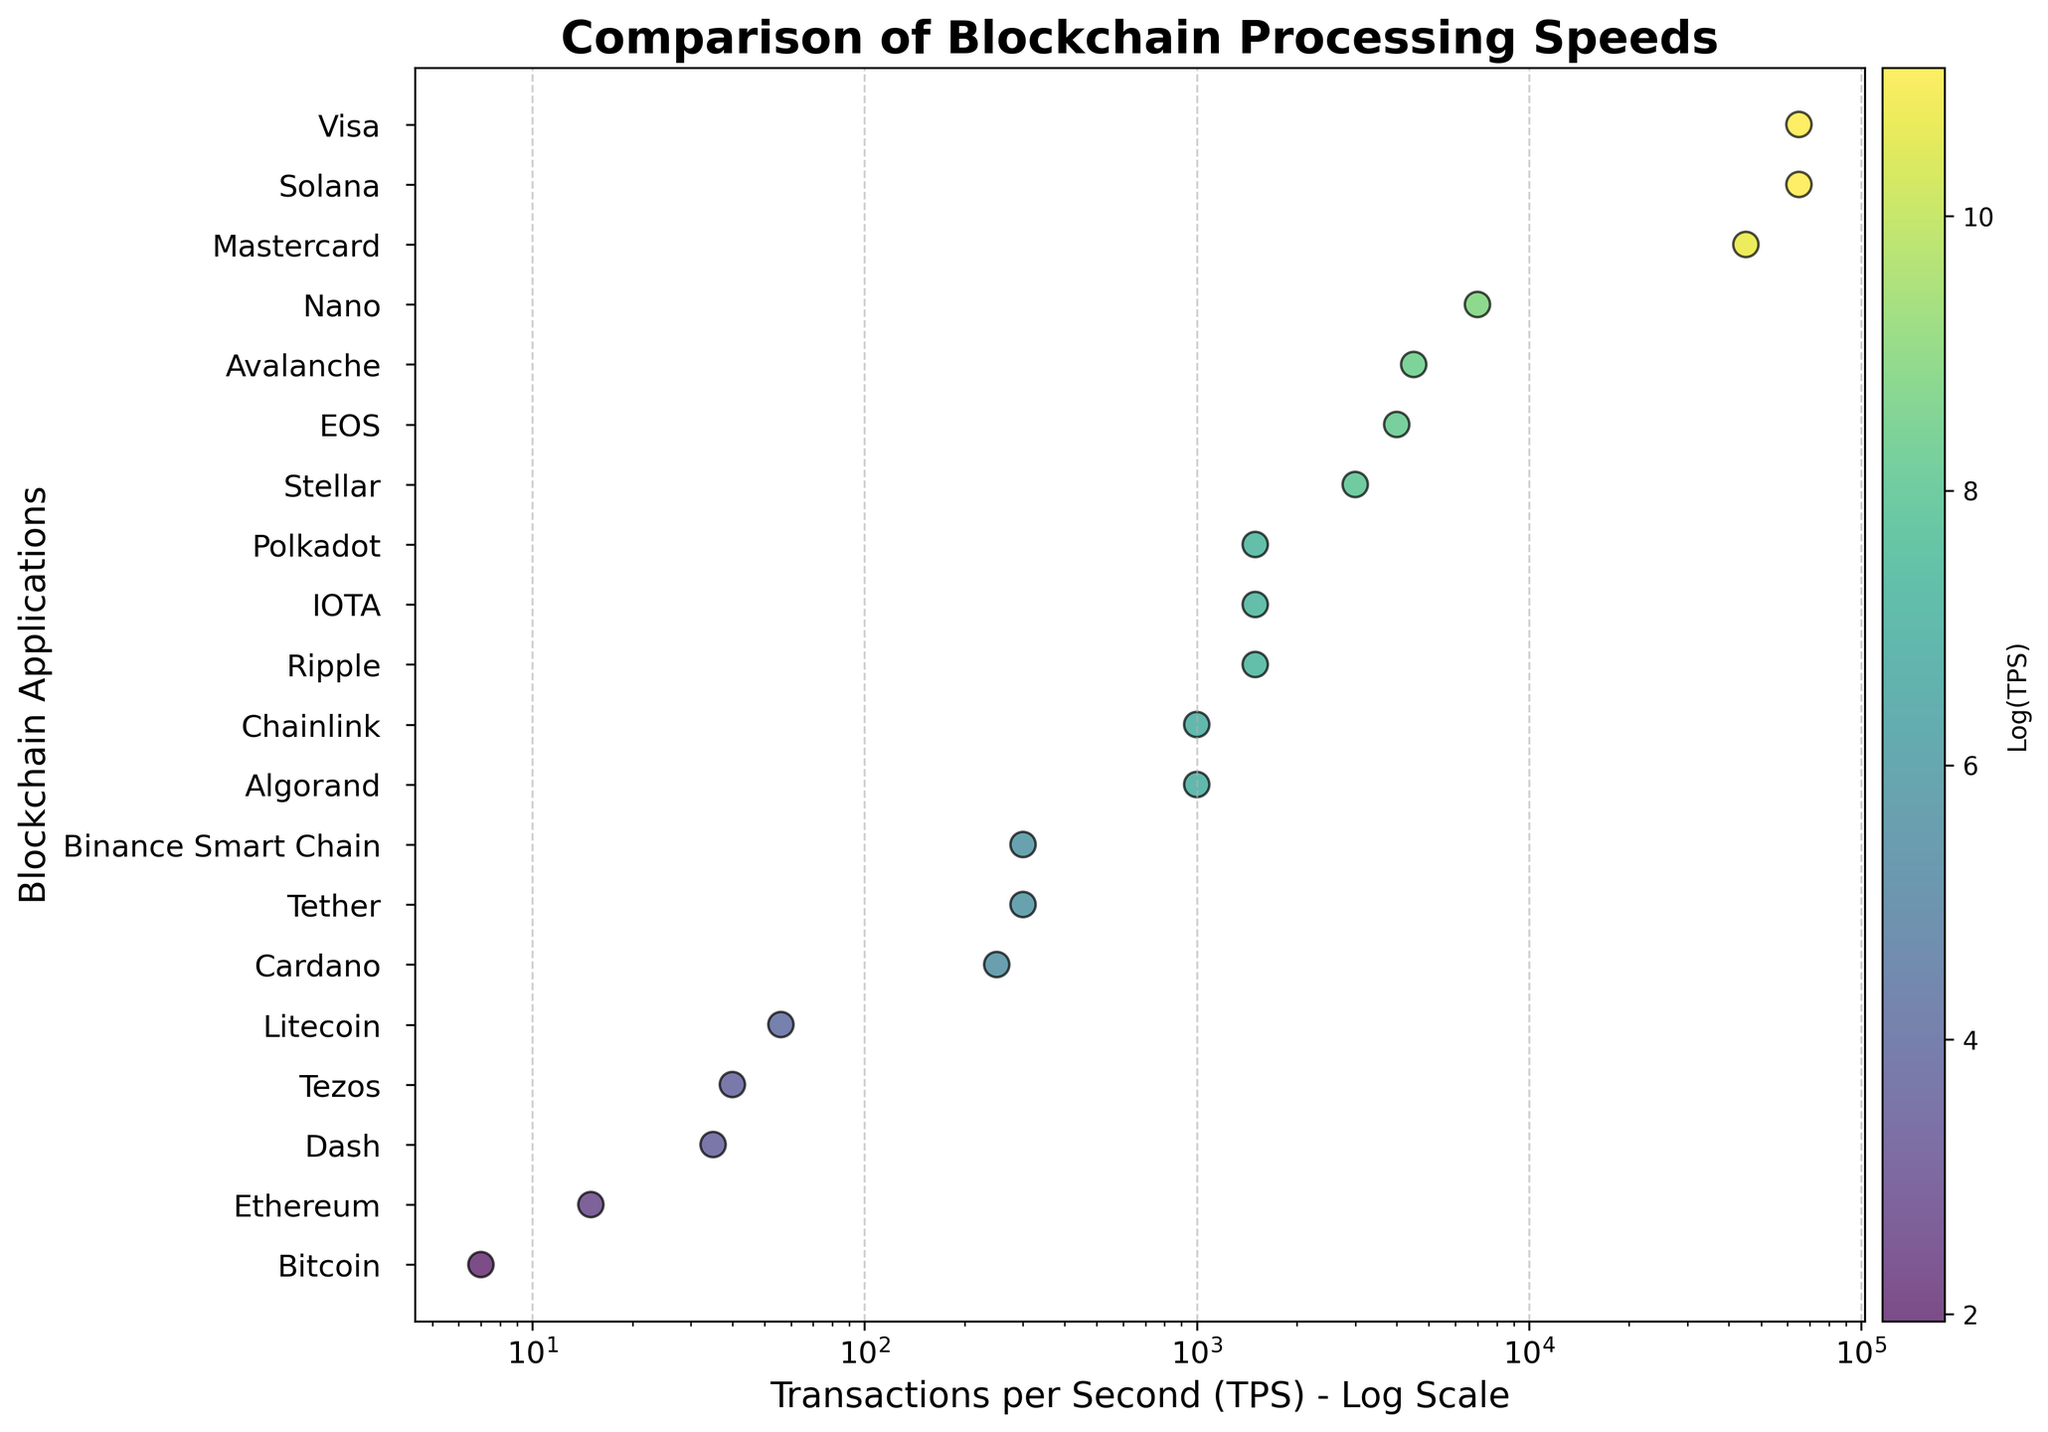What is the title of the plot? The title of the plot is placed at the top to give an idea about what the plot represents. Here, it reads "Comparison of Blockchain Processing Speeds."
Answer: Comparison of Blockchain Processing Speeds What are the axes labels in the plot? The x-axis represents "Transactions per Second (TPS) - Log Scale" and the y-axis labels "Blockchain Applications." This provides context for what is being compared and the scale used.
Answer: "Transactions per Second (TPS) - Log Scale" and "Blockchain Applications" How many data points are shown in the plot? Each data point represents a different blockchain application shown as a scatter plot. By counting these points visually, we see there are 21 data points.
Answer: 21 Which blockchain application has the highest Transactions per Second (TPS)? The highest TPS value is represented by the point farthest on the right on a logarithmic scale. This application is Visa with a TPS of 65,000.
Answer: Visa Which blockchain application has the lowest Transactions per Second (TPS)? The lowest TPS value is represented by the point farthest on the left on a logarithmic scale. This application is Bitcoin with a TPS of 7.
Answer: Bitcoin What is the Transactions per Second (TPS) for Solana? Locate the point corresponding to Solana on the plot. Its x-coordinate on the logarithmic scale shows a TPS of 65,000.
Answer: 65,000 How many blockchain applications have a TPS of 1000 or more? Count all points that are positioned at or above the 1000 TPS mark on the x-axis. Applications fitting this criteria include Ripple, Stellar, EOS, Avalanche, Nano, Solana, and Visa.
Answer: 7 What's the difference in TPS between Mastercard and Binace Smart Chain? Mastercard has a TPS of 45,000, while Binance Smart Chain has a TPS of 300. The difference is calculated by 45,000 - 300.
Answer: 44,700 Which blockchain applications have a TPS similar to Ripple? Ripple has a TPS of 1,500. Look for other points close to this value on the x-axis, which include Polkadot and IOTA.
Answer: Polkadot and IOTA What color represents the highest TPS values on the color scale? The color bar to the right shows a gradient from lower to higher log(TPS) values. The highest TPS values are colored in yellow.
Answer: Yellow 